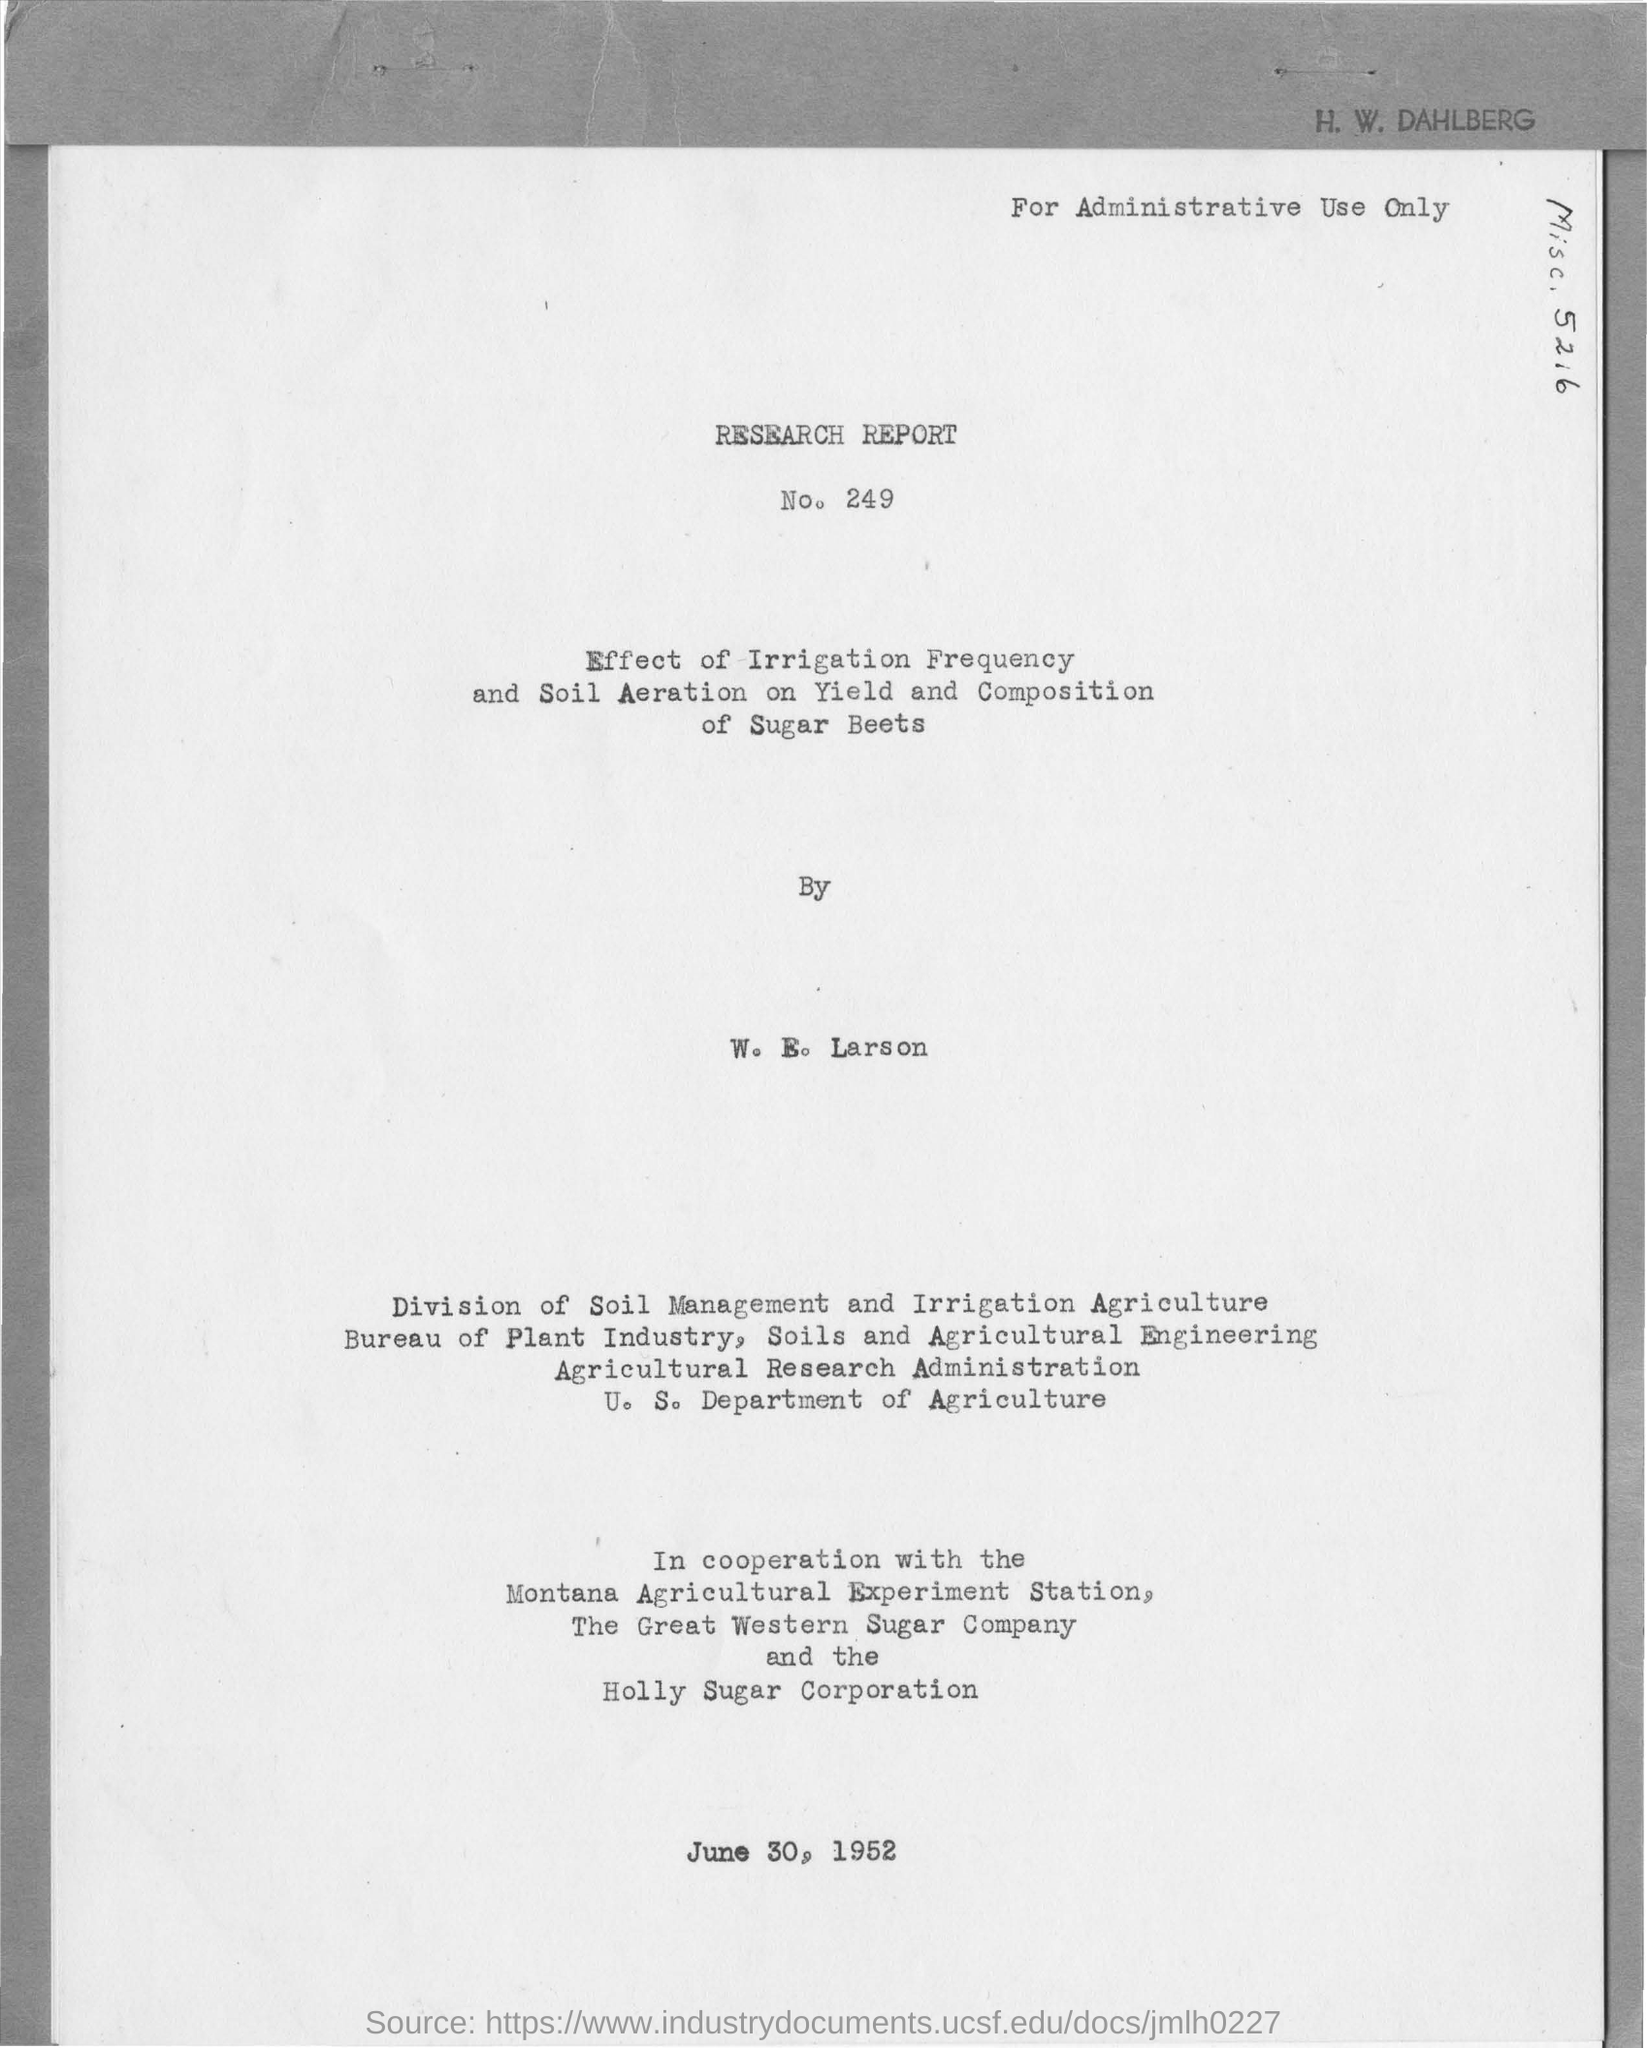What is the Name mentioned in the top right of the document ?
Your response must be concise. H. W. Dahlberg. What is the  number written in below the Research Report ?
Keep it short and to the point. 249. What is the name written in the below By?
Offer a very short reply. W. E. Larson. What is the date mentioned in the bottom of the document ?
Your answer should be compact. June 30, 1952. 